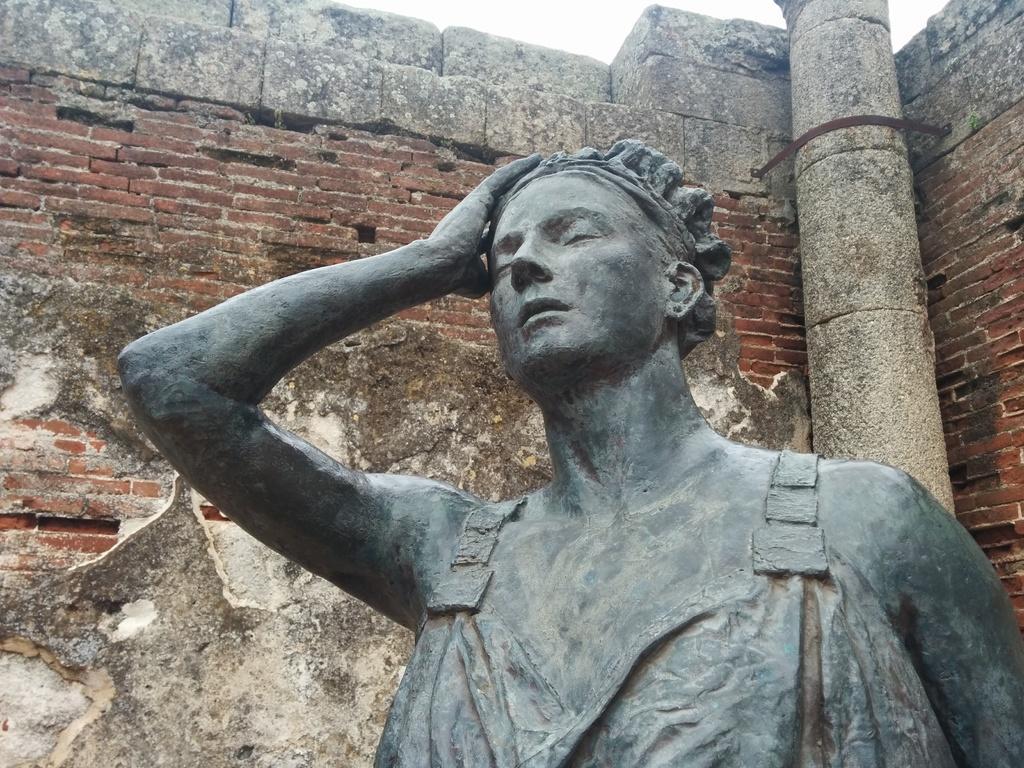Could you give a brief overview of what you see in this image? In this picture I can see there is a statue and there is a brick wall and a pillar in the backdrop and the sky is clear. 